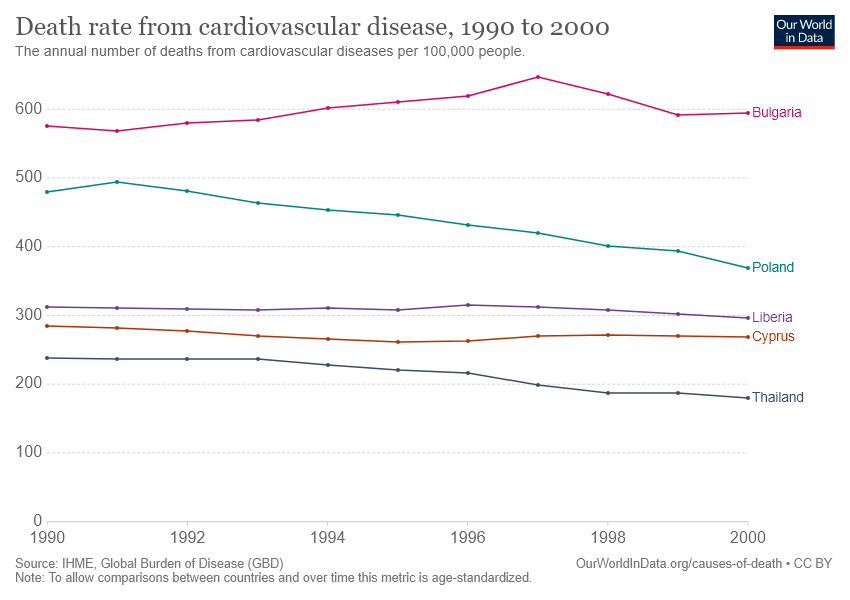Give some essential details in this illustration. The pink bar represents Bulgaria. The first point of the Bulgaria line can be approximated to have a value of approximately 575. 